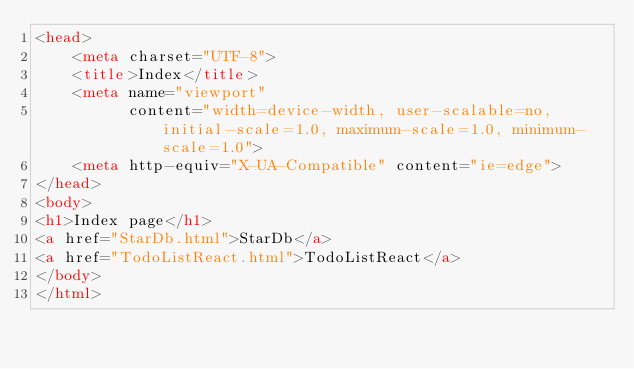Convert code to text. <code><loc_0><loc_0><loc_500><loc_500><_HTML_><head>
    <meta charset="UTF-8">
    <title>Index</title>
    <meta name="viewport"
          content="width=device-width, user-scalable=no, initial-scale=1.0, maximum-scale=1.0, minimum-scale=1.0">
    <meta http-equiv="X-UA-Compatible" content="ie=edge">
</head>
<body>
<h1>Index page</h1>
<a href="StarDb.html">StarDb</a>
<a href="TodoListReact.html">TodoListReact</a>
</body>
</html></code> 